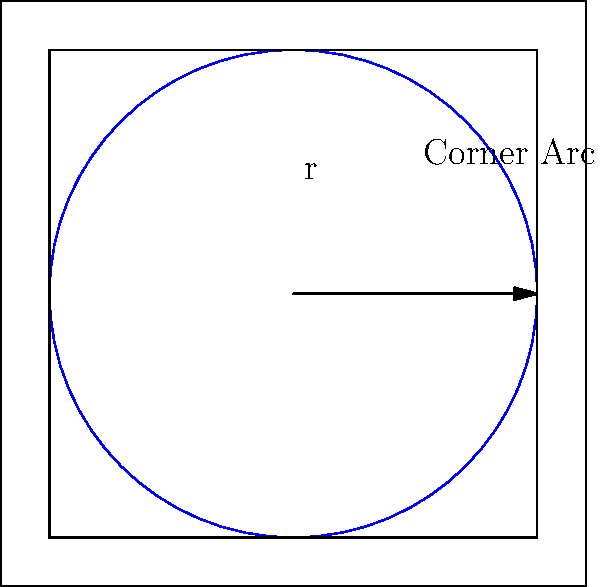In a standard football field, there are four corner arcs, each with a radius of 1 meter. Calculate the total area of all four corner arcs combined. Round your answer to two decimal places. To solve this problem, let's follow these steps:

1) The area of a circle is given by the formula $A = \pi r^2$, where $r$ is the radius.

2) For each corner arc:
   - Radius $r = 1$ meter
   - Area of a full circle would be $A = \pi (1)^2 = \pi$ square meters

3) However, we only need a quarter of this circle for each corner arc. So, the area of one corner arc is:
   $A_{corner} = \frac{1}{4} \pi$ square meters

4) There are four corner arcs in total, so we multiply by 4:
   $A_{total} = 4 \times \frac{1}{4} \pi = \pi$ square meters

5) Calculate the value of $\pi$ to two decimal places:
   $\pi \approx 3.14$ square meters

Therefore, the total area of all four corner arcs is approximately 3.14 square meters.
Answer: $3.14 \text{ m}^2$ 